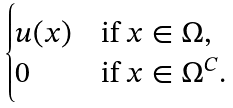<formula> <loc_0><loc_0><loc_500><loc_500>\begin{cases} u ( x ) & \text {if $x \in \Omega$} , \\ 0 & \text {if $x \in \Omega ^{C}$} . \end{cases}</formula> 